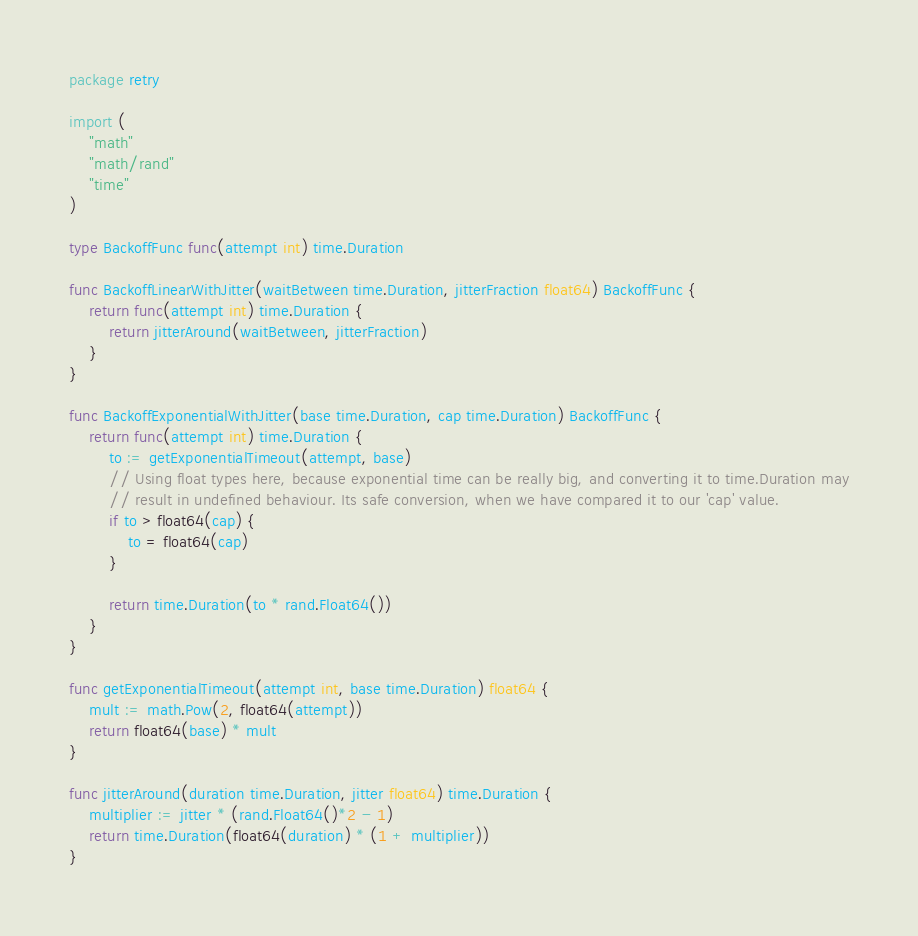<code> <loc_0><loc_0><loc_500><loc_500><_Go_>package retry

import (
	"math"
	"math/rand"
	"time"
)

type BackoffFunc func(attempt int) time.Duration

func BackoffLinearWithJitter(waitBetween time.Duration, jitterFraction float64) BackoffFunc {
	return func(attempt int) time.Duration {
		return jitterAround(waitBetween, jitterFraction)
	}
}

func BackoffExponentialWithJitter(base time.Duration, cap time.Duration) BackoffFunc {
	return func(attempt int) time.Duration {
		to := getExponentialTimeout(attempt, base)
		// Using float types here, because exponential time can be really big, and converting it to time.Duration may
		// result in undefined behaviour. Its safe conversion, when we have compared it to our 'cap' value.
		if to > float64(cap) {
			to = float64(cap)
		}

		return time.Duration(to * rand.Float64())
	}
}

func getExponentialTimeout(attempt int, base time.Duration) float64 {
	mult := math.Pow(2, float64(attempt))
	return float64(base) * mult
}

func jitterAround(duration time.Duration, jitter float64) time.Duration {
	multiplier := jitter * (rand.Float64()*2 - 1)
	return time.Duration(float64(duration) * (1 + multiplier))
}
</code> 